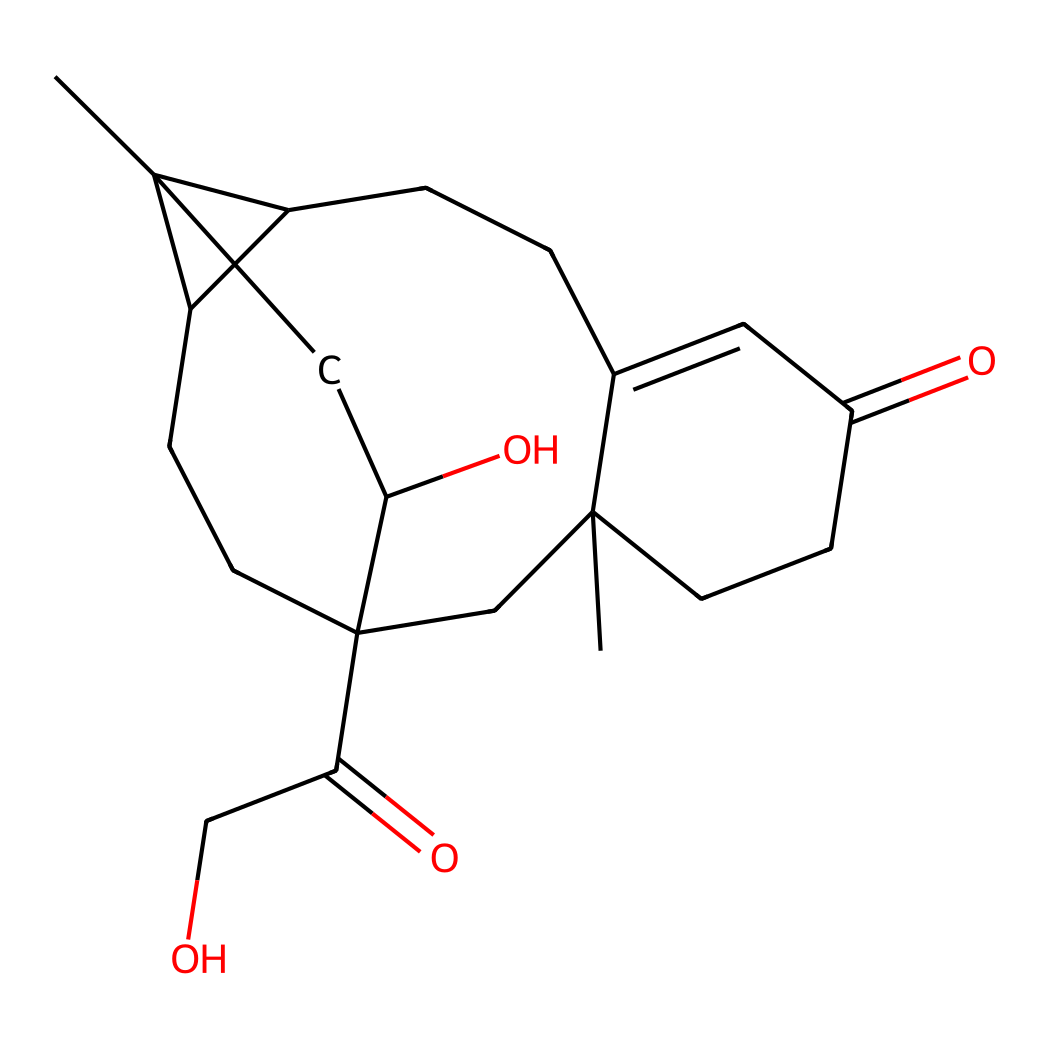how many carbon atoms are in cortisol? By analyzing the SMILES representation, we can count the number of 'C' characters that correspond to carbon atoms. The total count reveals there are 21 carbon atoms.
Answer: 21 what type of chemical structure does cortisol represent? The structure observed in the SMILES shows multiple rings and functional groups that categorize cortisol as a steroid hormone due to its four interconnected carbon rings and functional groups like hydroxyl and carbonyl.
Answer: steroid hormone how many oxygen atoms are present in cortisol? By inspecting the SMILES, we identify the 'O' characters, which indicate the number of oxygen atoms in the structure. There are five oxygen atoms depicted in cortisol.
Answer: 5 what functional groups are present in cortisol? The SMILES includes indications of hydroxyl (-OH) and carbonyl (C=O) groups present in cortisol, which are significant for its biochemical activity. The latter could be from ketones and aldehydes.
Answer: hydroxyl and carbonyl which features of cortisol allow it to act as a stress hormone? Cortisol's structure contains functional groups conducive to interaction with specific receptors in the body, and the presence of a cyclic structure allows for effective binding and modulation of physiological responses to stress.
Answer: cyclic structure and functional groups 